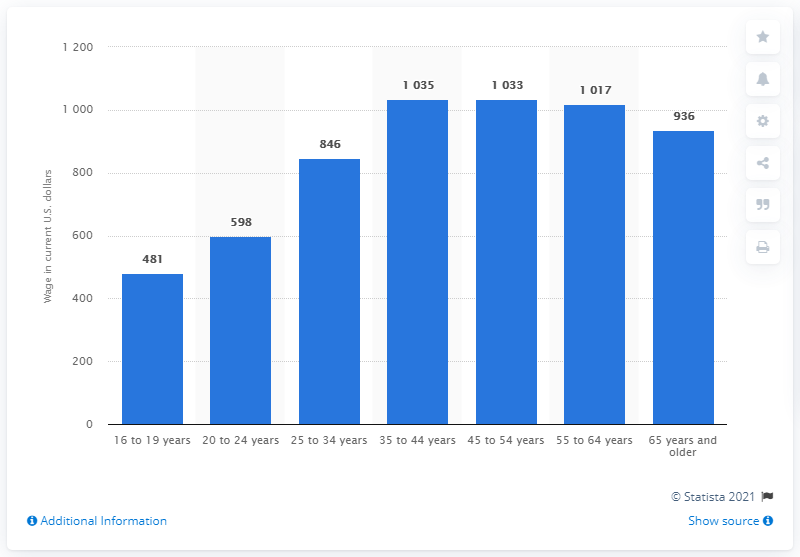Indicate a few pertinent items in this graphic. The median weekly earnings of a full-time employee between 16 and 19 years of age in 2019 was $481. 